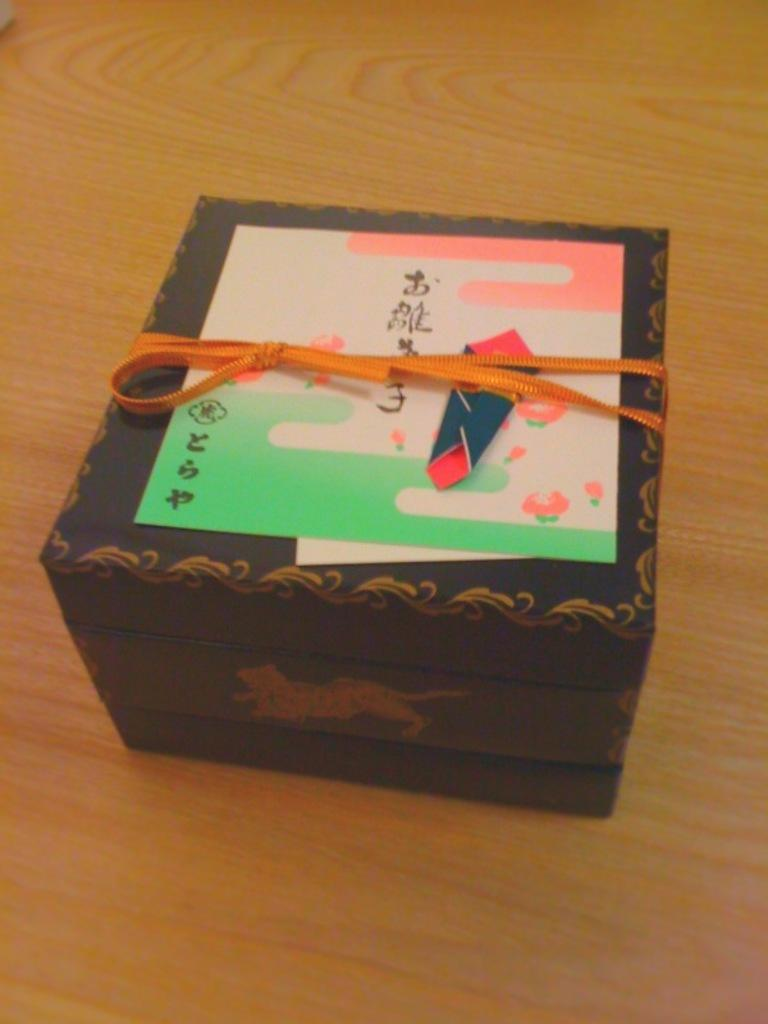<image>
Describe the image concisely. A gift in a box with a creature on the side on the top there is a card which is written in some asian language. 